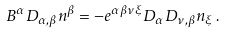<formula> <loc_0><loc_0><loc_500><loc_500>B ^ { \alpha } D _ { \alpha , \beta } n ^ { \beta } = - e ^ { \alpha \beta \nu \xi } D _ { \alpha } D _ { \nu , \beta } n _ { \xi } \, .</formula> 